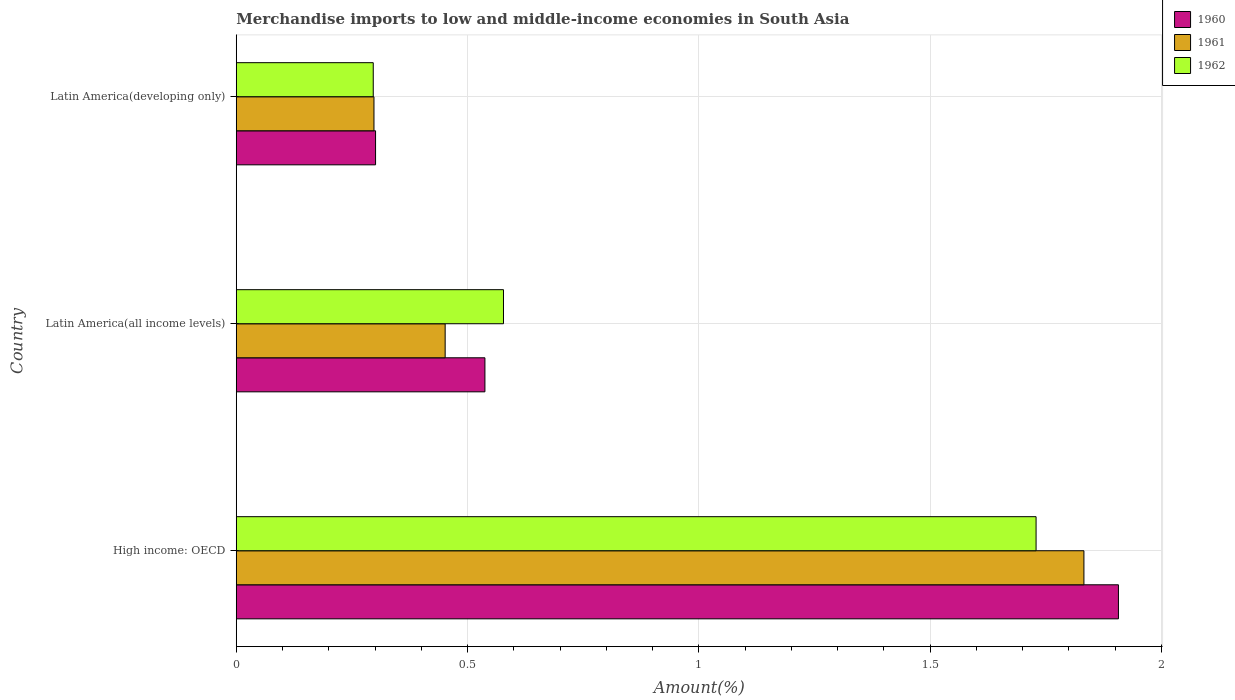How many groups of bars are there?
Provide a short and direct response. 3. What is the label of the 1st group of bars from the top?
Your answer should be compact. Latin America(developing only). What is the percentage of amount earned from merchandise imports in 1962 in Latin America(developing only)?
Your response must be concise. 0.3. Across all countries, what is the maximum percentage of amount earned from merchandise imports in 1961?
Ensure brevity in your answer.  1.83. Across all countries, what is the minimum percentage of amount earned from merchandise imports in 1960?
Offer a very short reply. 0.3. In which country was the percentage of amount earned from merchandise imports in 1960 maximum?
Provide a succinct answer. High income: OECD. In which country was the percentage of amount earned from merchandise imports in 1961 minimum?
Ensure brevity in your answer.  Latin America(developing only). What is the total percentage of amount earned from merchandise imports in 1960 in the graph?
Give a very brief answer. 2.75. What is the difference between the percentage of amount earned from merchandise imports in 1962 in High income: OECD and that in Latin America(developing only)?
Give a very brief answer. 1.43. What is the difference between the percentage of amount earned from merchandise imports in 1961 in High income: OECD and the percentage of amount earned from merchandise imports in 1960 in Latin America(all income levels)?
Provide a succinct answer. 1.29. What is the average percentage of amount earned from merchandise imports in 1961 per country?
Your answer should be compact. 0.86. What is the difference between the percentage of amount earned from merchandise imports in 1962 and percentage of amount earned from merchandise imports in 1961 in Latin America(all income levels)?
Provide a succinct answer. 0.13. What is the ratio of the percentage of amount earned from merchandise imports in 1960 in High income: OECD to that in Latin America(developing only)?
Your answer should be very brief. 6.33. Is the percentage of amount earned from merchandise imports in 1960 in High income: OECD less than that in Latin America(all income levels)?
Your response must be concise. No. Is the difference between the percentage of amount earned from merchandise imports in 1962 in High income: OECD and Latin America(developing only) greater than the difference between the percentage of amount earned from merchandise imports in 1961 in High income: OECD and Latin America(developing only)?
Provide a succinct answer. No. What is the difference between the highest and the second highest percentage of amount earned from merchandise imports in 1961?
Offer a terse response. 1.38. What is the difference between the highest and the lowest percentage of amount earned from merchandise imports in 1962?
Keep it short and to the point. 1.43. In how many countries, is the percentage of amount earned from merchandise imports in 1961 greater than the average percentage of amount earned from merchandise imports in 1961 taken over all countries?
Your response must be concise. 1. Is it the case that in every country, the sum of the percentage of amount earned from merchandise imports in 1962 and percentage of amount earned from merchandise imports in 1960 is greater than the percentage of amount earned from merchandise imports in 1961?
Give a very brief answer. Yes. Are all the bars in the graph horizontal?
Keep it short and to the point. Yes. How many countries are there in the graph?
Keep it short and to the point. 3. What is the difference between two consecutive major ticks on the X-axis?
Provide a short and direct response. 0.5. Are the values on the major ticks of X-axis written in scientific E-notation?
Provide a short and direct response. No. Does the graph contain any zero values?
Ensure brevity in your answer.  No. How are the legend labels stacked?
Provide a succinct answer. Vertical. What is the title of the graph?
Make the answer very short. Merchandise imports to low and middle-income economies in South Asia. What is the label or title of the X-axis?
Provide a short and direct response. Amount(%). What is the label or title of the Y-axis?
Provide a succinct answer. Country. What is the Amount(%) of 1960 in High income: OECD?
Keep it short and to the point. 1.91. What is the Amount(%) in 1961 in High income: OECD?
Offer a very short reply. 1.83. What is the Amount(%) of 1962 in High income: OECD?
Offer a terse response. 1.73. What is the Amount(%) of 1960 in Latin America(all income levels)?
Your answer should be very brief. 0.54. What is the Amount(%) of 1961 in Latin America(all income levels)?
Provide a succinct answer. 0.45. What is the Amount(%) in 1962 in Latin America(all income levels)?
Your answer should be compact. 0.58. What is the Amount(%) in 1960 in Latin America(developing only)?
Your response must be concise. 0.3. What is the Amount(%) in 1961 in Latin America(developing only)?
Give a very brief answer. 0.3. What is the Amount(%) in 1962 in Latin America(developing only)?
Your answer should be very brief. 0.3. Across all countries, what is the maximum Amount(%) in 1960?
Make the answer very short. 1.91. Across all countries, what is the maximum Amount(%) of 1961?
Your answer should be compact. 1.83. Across all countries, what is the maximum Amount(%) of 1962?
Your answer should be compact. 1.73. Across all countries, what is the minimum Amount(%) of 1960?
Give a very brief answer. 0.3. Across all countries, what is the minimum Amount(%) of 1961?
Your answer should be very brief. 0.3. Across all countries, what is the minimum Amount(%) in 1962?
Ensure brevity in your answer.  0.3. What is the total Amount(%) of 1960 in the graph?
Make the answer very short. 2.75. What is the total Amount(%) in 1961 in the graph?
Offer a very short reply. 2.58. What is the total Amount(%) of 1962 in the graph?
Keep it short and to the point. 2.6. What is the difference between the Amount(%) in 1960 in High income: OECD and that in Latin America(all income levels)?
Provide a short and direct response. 1.37. What is the difference between the Amount(%) of 1961 in High income: OECD and that in Latin America(all income levels)?
Your answer should be very brief. 1.38. What is the difference between the Amount(%) in 1962 in High income: OECD and that in Latin America(all income levels)?
Offer a terse response. 1.15. What is the difference between the Amount(%) in 1960 in High income: OECD and that in Latin America(developing only)?
Keep it short and to the point. 1.61. What is the difference between the Amount(%) in 1961 in High income: OECD and that in Latin America(developing only)?
Keep it short and to the point. 1.53. What is the difference between the Amount(%) of 1962 in High income: OECD and that in Latin America(developing only)?
Ensure brevity in your answer.  1.43. What is the difference between the Amount(%) in 1960 in Latin America(all income levels) and that in Latin America(developing only)?
Offer a very short reply. 0.24. What is the difference between the Amount(%) of 1961 in Latin America(all income levels) and that in Latin America(developing only)?
Provide a succinct answer. 0.15. What is the difference between the Amount(%) in 1962 in Latin America(all income levels) and that in Latin America(developing only)?
Give a very brief answer. 0.28. What is the difference between the Amount(%) in 1960 in High income: OECD and the Amount(%) in 1961 in Latin America(all income levels)?
Your answer should be compact. 1.46. What is the difference between the Amount(%) of 1960 in High income: OECD and the Amount(%) of 1962 in Latin America(all income levels)?
Your answer should be very brief. 1.33. What is the difference between the Amount(%) of 1961 in High income: OECD and the Amount(%) of 1962 in Latin America(all income levels)?
Your answer should be compact. 1.25. What is the difference between the Amount(%) of 1960 in High income: OECD and the Amount(%) of 1961 in Latin America(developing only)?
Provide a succinct answer. 1.61. What is the difference between the Amount(%) in 1960 in High income: OECD and the Amount(%) in 1962 in Latin America(developing only)?
Your answer should be compact. 1.61. What is the difference between the Amount(%) in 1961 in High income: OECD and the Amount(%) in 1962 in Latin America(developing only)?
Offer a terse response. 1.54. What is the difference between the Amount(%) of 1960 in Latin America(all income levels) and the Amount(%) of 1961 in Latin America(developing only)?
Your response must be concise. 0.24. What is the difference between the Amount(%) of 1960 in Latin America(all income levels) and the Amount(%) of 1962 in Latin America(developing only)?
Ensure brevity in your answer.  0.24. What is the difference between the Amount(%) of 1961 in Latin America(all income levels) and the Amount(%) of 1962 in Latin America(developing only)?
Keep it short and to the point. 0.16. What is the average Amount(%) of 1960 per country?
Your answer should be very brief. 0.92. What is the average Amount(%) of 1961 per country?
Your answer should be compact. 0.86. What is the average Amount(%) of 1962 per country?
Ensure brevity in your answer.  0.87. What is the difference between the Amount(%) of 1960 and Amount(%) of 1961 in High income: OECD?
Your answer should be very brief. 0.07. What is the difference between the Amount(%) of 1960 and Amount(%) of 1962 in High income: OECD?
Ensure brevity in your answer.  0.18. What is the difference between the Amount(%) in 1961 and Amount(%) in 1962 in High income: OECD?
Offer a very short reply. 0.1. What is the difference between the Amount(%) in 1960 and Amount(%) in 1961 in Latin America(all income levels)?
Your answer should be compact. 0.09. What is the difference between the Amount(%) of 1960 and Amount(%) of 1962 in Latin America(all income levels)?
Provide a short and direct response. -0.04. What is the difference between the Amount(%) of 1961 and Amount(%) of 1962 in Latin America(all income levels)?
Provide a succinct answer. -0.13. What is the difference between the Amount(%) of 1960 and Amount(%) of 1961 in Latin America(developing only)?
Provide a succinct answer. 0. What is the difference between the Amount(%) in 1960 and Amount(%) in 1962 in Latin America(developing only)?
Make the answer very short. 0.01. What is the difference between the Amount(%) of 1961 and Amount(%) of 1962 in Latin America(developing only)?
Make the answer very short. 0. What is the ratio of the Amount(%) in 1960 in High income: OECD to that in Latin America(all income levels)?
Make the answer very short. 3.55. What is the ratio of the Amount(%) in 1961 in High income: OECD to that in Latin America(all income levels)?
Make the answer very short. 4.06. What is the ratio of the Amount(%) of 1962 in High income: OECD to that in Latin America(all income levels)?
Provide a succinct answer. 2.99. What is the ratio of the Amount(%) in 1960 in High income: OECD to that in Latin America(developing only)?
Keep it short and to the point. 6.33. What is the ratio of the Amount(%) of 1961 in High income: OECD to that in Latin America(developing only)?
Make the answer very short. 6.16. What is the ratio of the Amount(%) of 1962 in High income: OECD to that in Latin America(developing only)?
Your response must be concise. 5.84. What is the ratio of the Amount(%) of 1960 in Latin America(all income levels) to that in Latin America(developing only)?
Your answer should be very brief. 1.78. What is the ratio of the Amount(%) of 1961 in Latin America(all income levels) to that in Latin America(developing only)?
Provide a succinct answer. 1.52. What is the ratio of the Amount(%) of 1962 in Latin America(all income levels) to that in Latin America(developing only)?
Give a very brief answer. 1.95. What is the difference between the highest and the second highest Amount(%) in 1960?
Offer a very short reply. 1.37. What is the difference between the highest and the second highest Amount(%) in 1961?
Ensure brevity in your answer.  1.38. What is the difference between the highest and the second highest Amount(%) of 1962?
Your answer should be very brief. 1.15. What is the difference between the highest and the lowest Amount(%) of 1960?
Your response must be concise. 1.61. What is the difference between the highest and the lowest Amount(%) of 1961?
Offer a terse response. 1.53. What is the difference between the highest and the lowest Amount(%) in 1962?
Provide a short and direct response. 1.43. 